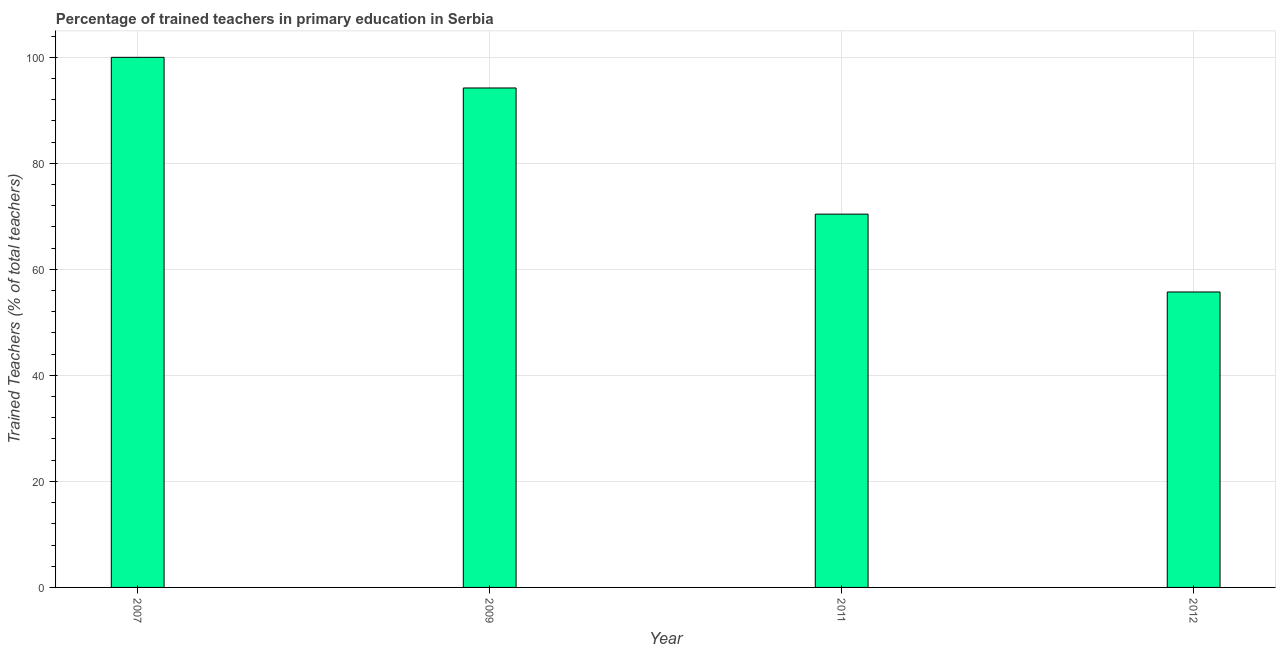Does the graph contain any zero values?
Offer a terse response. No. What is the title of the graph?
Your answer should be compact. Percentage of trained teachers in primary education in Serbia. What is the label or title of the X-axis?
Provide a succinct answer. Year. What is the label or title of the Y-axis?
Provide a succinct answer. Trained Teachers (% of total teachers). What is the percentage of trained teachers in 2007?
Offer a terse response. 100. Across all years, what is the maximum percentage of trained teachers?
Make the answer very short. 100. Across all years, what is the minimum percentage of trained teachers?
Your response must be concise. 55.73. In which year was the percentage of trained teachers maximum?
Your answer should be very brief. 2007. What is the sum of the percentage of trained teachers?
Your response must be concise. 320.37. What is the difference between the percentage of trained teachers in 2011 and 2012?
Provide a succinct answer. 14.69. What is the average percentage of trained teachers per year?
Your response must be concise. 80.09. What is the median percentage of trained teachers?
Make the answer very short. 82.32. Do a majority of the years between 2009 and 2011 (inclusive) have percentage of trained teachers greater than 16 %?
Make the answer very short. Yes. What is the ratio of the percentage of trained teachers in 2009 to that in 2011?
Offer a very short reply. 1.34. Is the percentage of trained teachers in 2007 less than that in 2009?
Give a very brief answer. No. What is the difference between the highest and the second highest percentage of trained teachers?
Provide a succinct answer. 5.78. Is the sum of the percentage of trained teachers in 2007 and 2009 greater than the maximum percentage of trained teachers across all years?
Give a very brief answer. Yes. What is the difference between the highest and the lowest percentage of trained teachers?
Keep it short and to the point. 44.27. In how many years, is the percentage of trained teachers greater than the average percentage of trained teachers taken over all years?
Offer a very short reply. 2. How many bars are there?
Provide a succinct answer. 4. Are all the bars in the graph horizontal?
Your answer should be compact. No. How many years are there in the graph?
Provide a succinct answer. 4. Are the values on the major ticks of Y-axis written in scientific E-notation?
Provide a short and direct response. No. What is the Trained Teachers (% of total teachers) of 2007?
Offer a very short reply. 100. What is the Trained Teachers (% of total teachers) in 2009?
Offer a terse response. 94.22. What is the Trained Teachers (% of total teachers) in 2011?
Offer a very short reply. 70.42. What is the Trained Teachers (% of total teachers) of 2012?
Ensure brevity in your answer.  55.73. What is the difference between the Trained Teachers (% of total teachers) in 2007 and 2009?
Your response must be concise. 5.78. What is the difference between the Trained Teachers (% of total teachers) in 2007 and 2011?
Give a very brief answer. 29.58. What is the difference between the Trained Teachers (% of total teachers) in 2007 and 2012?
Make the answer very short. 44.27. What is the difference between the Trained Teachers (% of total teachers) in 2009 and 2011?
Ensure brevity in your answer.  23.8. What is the difference between the Trained Teachers (% of total teachers) in 2009 and 2012?
Make the answer very short. 38.48. What is the difference between the Trained Teachers (% of total teachers) in 2011 and 2012?
Give a very brief answer. 14.69. What is the ratio of the Trained Teachers (% of total teachers) in 2007 to that in 2009?
Provide a short and direct response. 1.06. What is the ratio of the Trained Teachers (% of total teachers) in 2007 to that in 2011?
Provide a short and direct response. 1.42. What is the ratio of the Trained Teachers (% of total teachers) in 2007 to that in 2012?
Make the answer very short. 1.79. What is the ratio of the Trained Teachers (% of total teachers) in 2009 to that in 2011?
Offer a very short reply. 1.34. What is the ratio of the Trained Teachers (% of total teachers) in 2009 to that in 2012?
Make the answer very short. 1.69. What is the ratio of the Trained Teachers (% of total teachers) in 2011 to that in 2012?
Your answer should be compact. 1.26. 